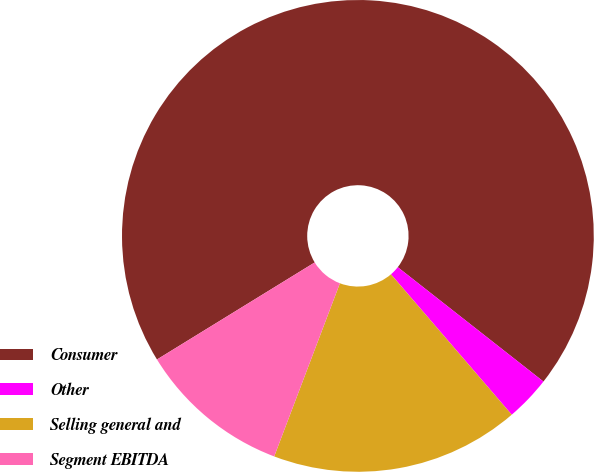Convert chart to OTSL. <chart><loc_0><loc_0><loc_500><loc_500><pie_chart><fcel>Consumer<fcel>Other<fcel>Selling general and<fcel>Segment EBITDA<nl><fcel>69.37%<fcel>3.1%<fcel>17.08%<fcel>10.45%<nl></chart> 